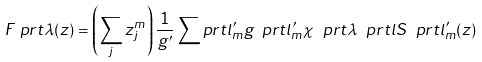<formula> <loc_0><loc_0><loc_500><loc_500>F _ { \ } p r t { \lambda } ( z ) = \left ( \sum _ { j } z _ { j } ^ { m } \right ) \frac { 1 } { g ^ { \prime } } \sum _ { \ } p r t { l _ { m } ^ { \prime } } g _ { \ } p r t { l _ { m } ^ { \prime } } \chi ^ { \ } p r t { \lambda } _ { \ } p r t { l } S _ { \ } p r t { l _ { m } ^ { \prime } } ( z )</formula> 